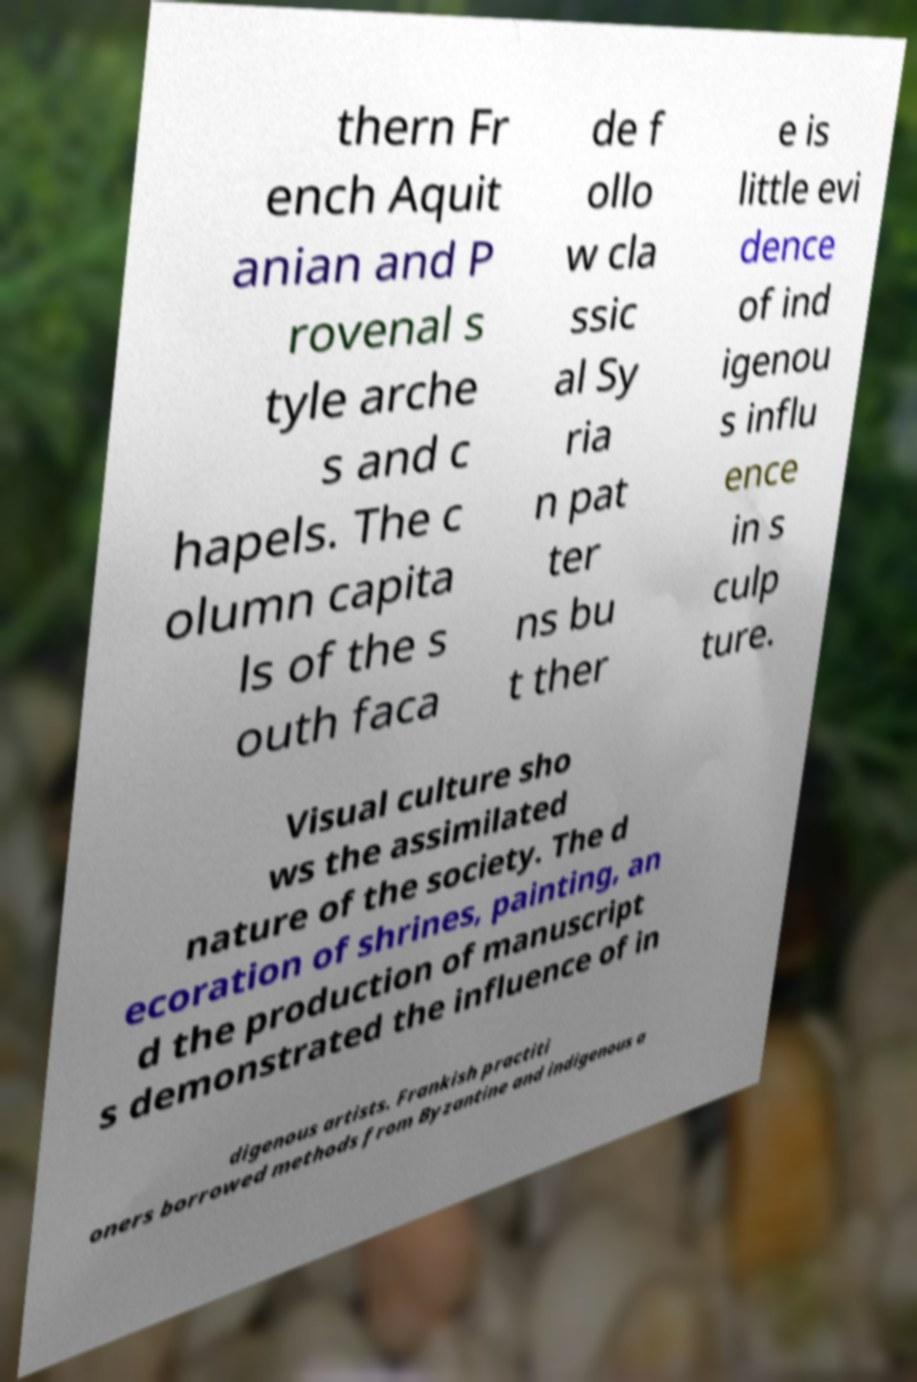There's text embedded in this image that I need extracted. Can you transcribe it verbatim? thern Fr ench Aquit anian and P rovenal s tyle arche s and c hapels. The c olumn capita ls of the s outh faca de f ollo w cla ssic al Sy ria n pat ter ns bu t ther e is little evi dence of ind igenou s influ ence in s culp ture. Visual culture sho ws the assimilated nature of the society. The d ecoration of shrines, painting, an d the production of manuscript s demonstrated the influence of in digenous artists. Frankish practiti oners borrowed methods from Byzantine and indigenous a 